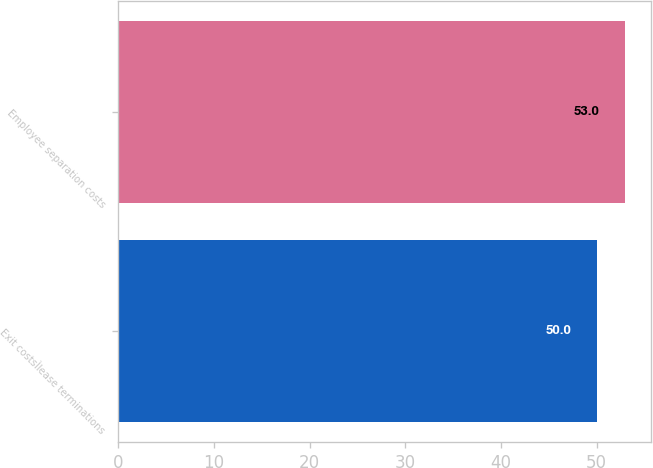Convert chart. <chart><loc_0><loc_0><loc_500><loc_500><bar_chart><fcel>Exit costsÌlease terminations<fcel>Employee separation costs<nl><fcel>50<fcel>53<nl></chart> 